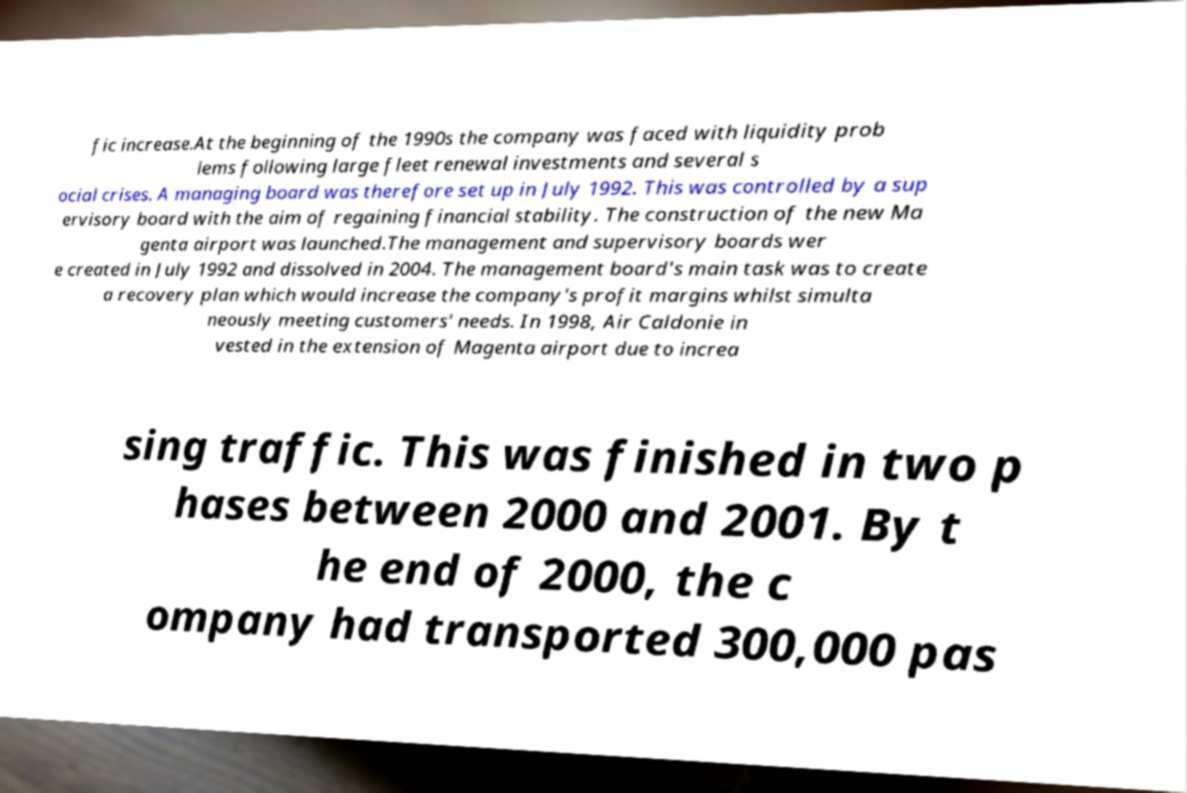Please read and relay the text visible in this image. What does it say? fic increase.At the beginning of the 1990s the company was faced with liquidity prob lems following large fleet renewal investments and several s ocial crises. A managing board was therefore set up in July 1992. This was controlled by a sup ervisory board with the aim of regaining financial stability. The construction of the new Ma genta airport was launched.The management and supervisory boards wer e created in July 1992 and dissolved in 2004. The management board's main task was to create a recovery plan which would increase the company's profit margins whilst simulta neously meeting customers' needs. In 1998, Air Caldonie in vested in the extension of Magenta airport due to increa sing traffic. This was finished in two p hases between 2000 and 2001. By t he end of 2000, the c ompany had transported 300,000 pas 